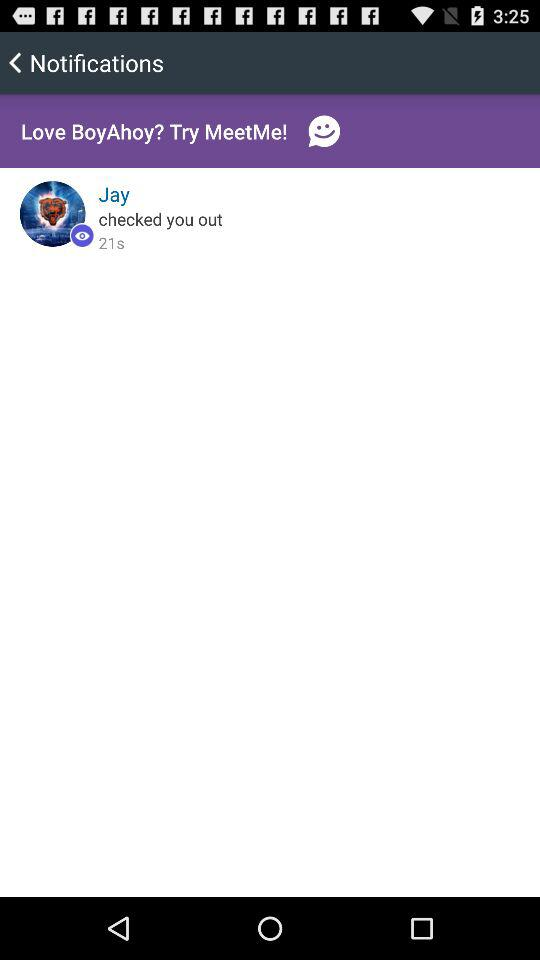When did Jay check out? Jay checked out 21seconds ago. 